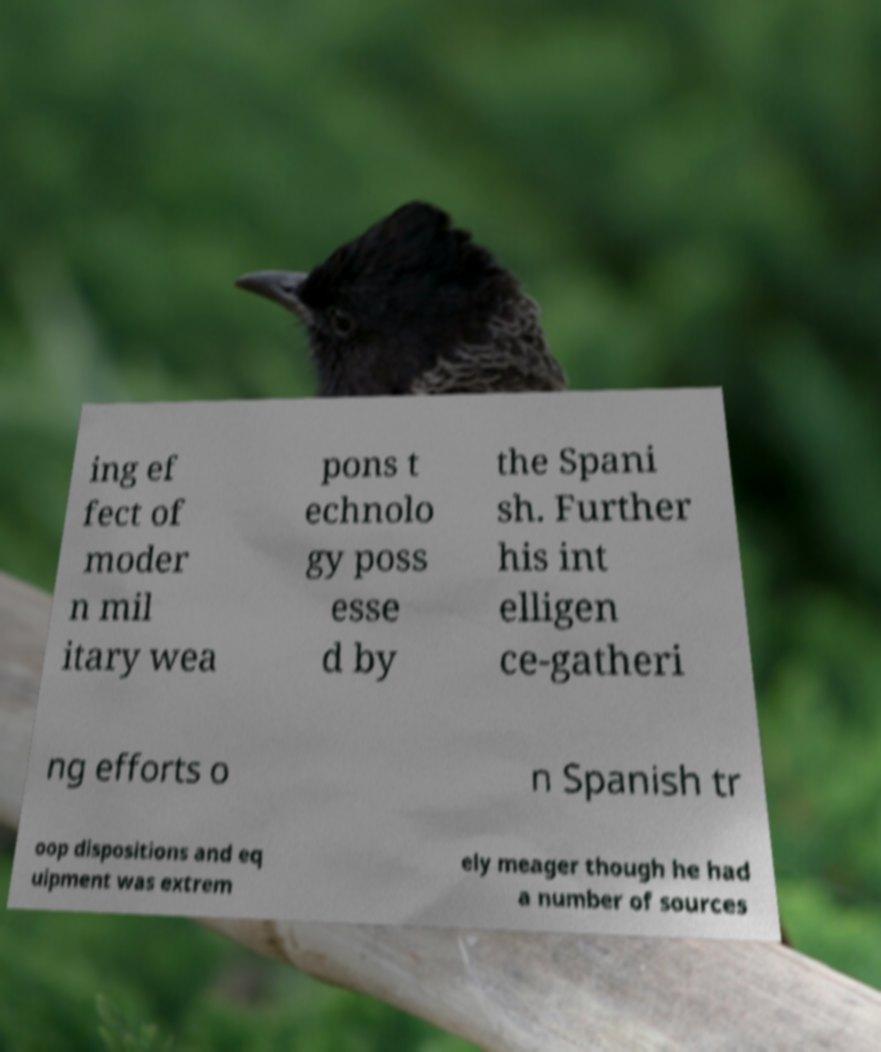Could you extract and type out the text from this image? ing ef fect of moder n mil itary wea pons t echnolo gy poss esse d by the Spani sh. Further his int elligen ce-gatheri ng efforts o n Spanish tr oop dispositions and eq uipment was extrem ely meager though he had a number of sources 